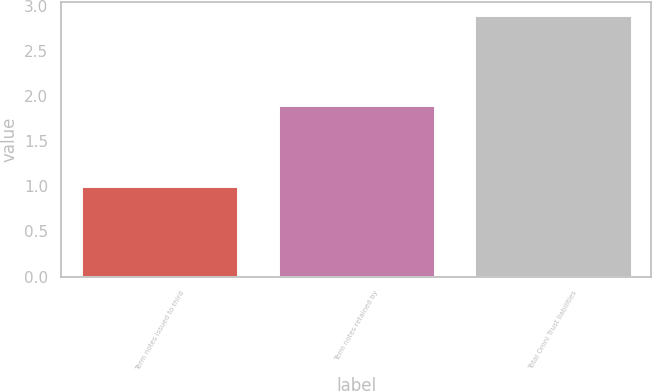Convert chart to OTSL. <chart><loc_0><loc_0><loc_500><loc_500><bar_chart><fcel>Term notes issued to third<fcel>Term notes retained by<fcel>Total Omni Trust liabilities<nl><fcel>1<fcel>1.9<fcel>2.9<nl></chart> 